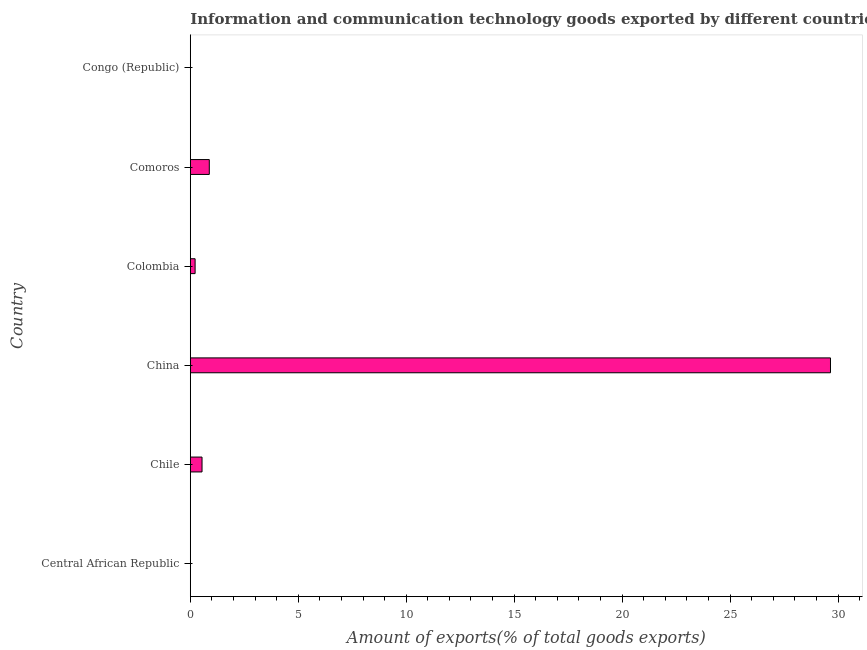Does the graph contain grids?
Offer a terse response. No. What is the title of the graph?
Provide a short and direct response. Information and communication technology goods exported by different countries. What is the label or title of the X-axis?
Give a very brief answer. Amount of exports(% of total goods exports). What is the amount of ict goods exports in Chile?
Give a very brief answer. 0.54. Across all countries, what is the maximum amount of ict goods exports?
Provide a succinct answer. 29.65. Across all countries, what is the minimum amount of ict goods exports?
Ensure brevity in your answer.  0.01. In which country was the amount of ict goods exports minimum?
Your answer should be very brief. Congo (Republic). What is the sum of the amount of ict goods exports?
Your response must be concise. 31.31. What is the difference between the amount of ict goods exports in China and Comoros?
Offer a terse response. 28.77. What is the average amount of ict goods exports per country?
Offer a very short reply. 5.22. What is the median amount of ict goods exports?
Offer a very short reply. 0.38. What is the ratio of the amount of ict goods exports in Central African Republic to that in Comoros?
Keep it short and to the point. 0.01. What is the difference between the highest and the second highest amount of ict goods exports?
Give a very brief answer. 28.77. Is the sum of the amount of ict goods exports in Chile and China greater than the maximum amount of ict goods exports across all countries?
Your answer should be very brief. Yes. What is the difference between the highest and the lowest amount of ict goods exports?
Ensure brevity in your answer.  29.64. In how many countries, is the amount of ict goods exports greater than the average amount of ict goods exports taken over all countries?
Keep it short and to the point. 1. How many bars are there?
Give a very brief answer. 6. Are all the bars in the graph horizontal?
Ensure brevity in your answer.  Yes. How many countries are there in the graph?
Your answer should be compact. 6. What is the Amount of exports(% of total goods exports) of Central African Republic?
Give a very brief answer. 0.01. What is the Amount of exports(% of total goods exports) in Chile?
Ensure brevity in your answer.  0.54. What is the Amount of exports(% of total goods exports) in China?
Give a very brief answer. 29.65. What is the Amount of exports(% of total goods exports) in Colombia?
Offer a very short reply. 0.22. What is the Amount of exports(% of total goods exports) of Comoros?
Your answer should be very brief. 0.88. What is the Amount of exports(% of total goods exports) in Congo (Republic)?
Your answer should be very brief. 0.01. What is the difference between the Amount of exports(% of total goods exports) in Central African Republic and Chile?
Provide a short and direct response. -0.54. What is the difference between the Amount of exports(% of total goods exports) in Central African Republic and China?
Your response must be concise. -29.64. What is the difference between the Amount of exports(% of total goods exports) in Central African Republic and Colombia?
Ensure brevity in your answer.  -0.21. What is the difference between the Amount of exports(% of total goods exports) in Central African Republic and Comoros?
Offer a terse response. -0.87. What is the difference between the Amount of exports(% of total goods exports) in Central African Republic and Congo (Republic)?
Ensure brevity in your answer.  0. What is the difference between the Amount of exports(% of total goods exports) in Chile and China?
Give a very brief answer. -29.11. What is the difference between the Amount of exports(% of total goods exports) in Chile and Colombia?
Your answer should be very brief. 0.32. What is the difference between the Amount of exports(% of total goods exports) in Chile and Comoros?
Keep it short and to the point. -0.34. What is the difference between the Amount of exports(% of total goods exports) in Chile and Congo (Republic)?
Ensure brevity in your answer.  0.54. What is the difference between the Amount of exports(% of total goods exports) in China and Colombia?
Ensure brevity in your answer.  29.43. What is the difference between the Amount of exports(% of total goods exports) in China and Comoros?
Ensure brevity in your answer.  28.77. What is the difference between the Amount of exports(% of total goods exports) in China and Congo (Republic)?
Ensure brevity in your answer.  29.64. What is the difference between the Amount of exports(% of total goods exports) in Colombia and Comoros?
Give a very brief answer. -0.66. What is the difference between the Amount of exports(% of total goods exports) in Colombia and Congo (Republic)?
Make the answer very short. 0.22. What is the difference between the Amount of exports(% of total goods exports) in Comoros and Congo (Republic)?
Ensure brevity in your answer.  0.87. What is the ratio of the Amount of exports(% of total goods exports) in Central African Republic to that in Chile?
Your answer should be very brief. 0.02. What is the ratio of the Amount of exports(% of total goods exports) in Central African Republic to that in China?
Make the answer very short. 0. What is the ratio of the Amount of exports(% of total goods exports) in Central African Republic to that in Colombia?
Your answer should be compact. 0.04. What is the ratio of the Amount of exports(% of total goods exports) in Central African Republic to that in Comoros?
Make the answer very short. 0.01. What is the ratio of the Amount of exports(% of total goods exports) in Central African Republic to that in Congo (Republic)?
Keep it short and to the point. 1.2. What is the ratio of the Amount of exports(% of total goods exports) in Chile to that in China?
Your answer should be compact. 0.02. What is the ratio of the Amount of exports(% of total goods exports) in Chile to that in Colombia?
Provide a succinct answer. 2.44. What is the ratio of the Amount of exports(% of total goods exports) in Chile to that in Comoros?
Make the answer very short. 0.62. What is the ratio of the Amount of exports(% of total goods exports) in Chile to that in Congo (Republic)?
Make the answer very short. 77.22. What is the ratio of the Amount of exports(% of total goods exports) in China to that in Colombia?
Your answer should be compact. 133.11. What is the ratio of the Amount of exports(% of total goods exports) in China to that in Comoros?
Give a very brief answer. 33.68. What is the ratio of the Amount of exports(% of total goods exports) in China to that in Congo (Republic)?
Make the answer very short. 4210.77. What is the ratio of the Amount of exports(% of total goods exports) in Colombia to that in Comoros?
Your answer should be compact. 0.25. What is the ratio of the Amount of exports(% of total goods exports) in Colombia to that in Congo (Republic)?
Offer a very short reply. 31.63. What is the ratio of the Amount of exports(% of total goods exports) in Comoros to that in Congo (Republic)?
Your answer should be very brief. 125.02. 